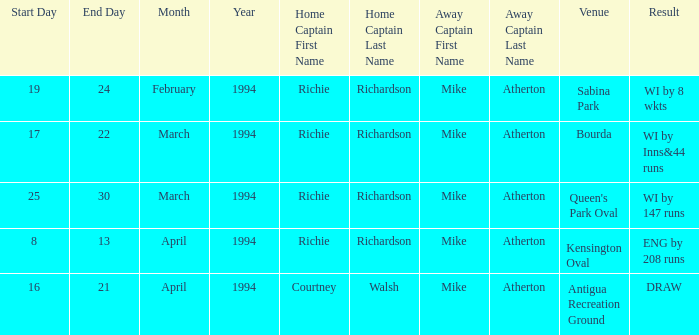Parse the table in full. {'header': ['Start Day', 'End Day', 'Month', 'Year', 'Home Captain First Name', 'Home Captain Last Name', 'Away Captain First Name', 'Away Captain Last Name', 'Venue', 'Result'], 'rows': [['19', '24', 'February', '1994', 'Richie', 'Richardson', 'Mike', 'Atherton', 'Sabina Park', 'WI by 8 wkts'], ['17', '22', 'March', '1994', 'Richie', 'Richardson', 'Mike', 'Atherton', 'Bourda', 'WI by Inns&44 runs'], ['25', '30', 'March', '1994', 'Richie', 'Richardson', 'Mike', 'Atherton', "Queen's Park Oval", 'WI by 147 runs'], ['8', '13', 'April', '1994', 'Richie', 'Richardson', 'Mike', 'Atherton', 'Kensington Oval', 'ENG by 208 runs'], ['16', '21', 'April', '1994', 'Courtney', 'Walsh', 'Mike', 'Atherton', 'Antigua Recreation Ground', 'DRAW']]} When did something occur at the antigua recreation ground venue? 16,17,18,20,21 April 1994. 